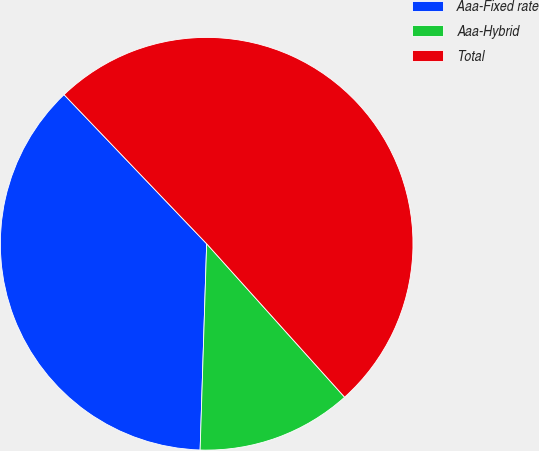<chart> <loc_0><loc_0><loc_500><loc_500><pie_chart><fcel>Aaa-Fixed rate<fcel>Aaa-Hybrid<fcel>Total<nl><fcel>37.35%<fcel>12.16%<fcel>50.49%<nl></chart> 